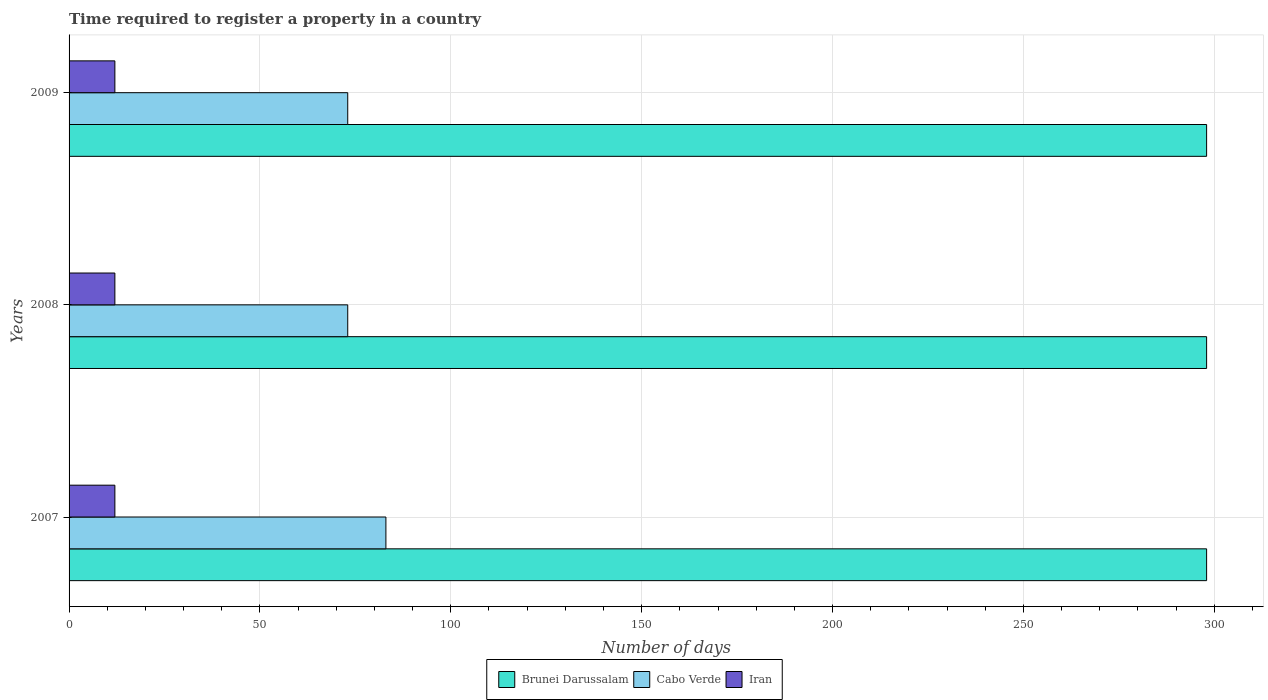Are the number of bars per tick equal to the number of legend labels?
Offer a very short reply. Yes. Are the number of bars on each tick of the Y-axis equal?
Keep it short and to the point. Yes. What is the label of the 1st group of bars from the top?
Your response must be concise. 2009. In how many cases, is the number of bars for a given year not equal to the number of legend labels?
Offer a very short reply. 0. What is the number of days required to register a property in Brunei Darussalam in 2008?
Your answer should be very brief. 298. Across all years, what is the maximum number of days required to register a property in Iran?
Provide a succinct answer. 12. In which year was the number of days required to register a property in Brunei Darussalam maximum?
Your answer should be very brief. 2007. In which year was the number of days required to register a property in Cabo Verde minimum?
Offer a very short reply. 2008. What is the total number of days required to register a property in Iran in the graph?
Give a very brief answer. 36. What is the difference between the number of days required to register a property in Brunei Darussalam in 2007 and that in 2009?
Provide a short and direct response. 0. What is the difference between the number of days required to register a property in Brunei Darussalam in 2009 and the number of days required to register a property in Iran in 2008?
Provide a short and direct response. 286. What is the average number of days required to register a property in Brunei Darussalam per year?
Make the answer very short. 298. In the year 2008, what is the difference between the number of days required to register a property in Iran and number of days required to register a property in Cabo Verde?
Your answer should be compact. -61. What is the ratio of the number of days required to register a property in Iran in 2007 to that in 2009?
Your answer should be very brief. 1. Is the difference between the number of days required to register a property in Iran in 2007 and 2008 greater than the difference between the number of days required to register a property in Cabo Verde in 2007 and 2008?
Ensure brevity in your answer.  No. What is the difference between the highest and the lowest number of days required to register a property in Iran?
Offer a terse response. 0. In how many years, is the number of days required to register a property in Iran greater than the average number of days required to register a property in Iran taken over all years?
Your answer should be very brief. 0. What does the 1st bar from the top in 2008 represents?
Provide a succinct answer. Iran. What does the 3rd bar from the bottom in 2007 represents?
Your response must be concise. Iran. Is it the case that in every year, the sum of the number of days required to register a property in Cabo Verde and number of days required to register a property in Iran is greater than the number of days required to register a property in Brunei Darussalam?
Ensure brevity in your answer.  No. How many years are there in the graph?
Keep it short and to the point. 3. What is the difference between two consecutive major ticks on the X-axis?
Your answer should be compact. 50. Does the graph contain any zero values?
Your answer should be very brief. No. Where does the legend appear in the graph?
Provide a succinct answer. Bottom center. How many legend labels are there?
Your response must be concise. 3. How are the legend labels stacked?
Provide a succinct answer. Horizontal. What is the title of the graph?
Provide a succinct answer. Time required to register a property in a country. What is the label or title of the X-axis?
Offer a very short reply. Number of days. What is the label or title of the Y-axis?
Ensure brevity in your answer.  Years. What is the Number of days in Brunei Darussalam in 2007?
Give a very brief answer. 298. What is the Number of days in Iran in 2007?
Keep it short and to the point. 12. What is the Number of days of Brunei Darussalam in 2008?
Ensure brevity in your answer.  298. What is the Number of days in Cabo Verde in 2008?
Offer a very short reply. 73. What is the Number of days in Iran in 2008?
Provide a short and direct response. 12. What is the Number of days of Brunei Darussalam in 2009?
Provide a succinct answer. 298. What is the Number of days in Cabo Verde in 2009?
Your response must be concise. 73. What is the Number of days of Iran in 2009?
Your answer should be compact. 12. Across all years, what is the maximum Number of days in Brunei Darussalam?
Provide a succinct answer. 298. Across all years, what is the maximum Number of days of Iran?
Ensure brevity in your answer.  12. Across all years, what is the minimum Number of days of Brunei Darussalam?
Give a very brief answer. 298. Across all years, what is the minimum Number of days of Cabo Verde?
Provide a succinct answer. 73. Across all years, what is the minimum Number of days in Iran?
Your answer should be very brief. 12. What is the total Number of days in Brunei Darussalam in the graph?
Offer a very short reply. 894. What is the total Number of days of Cabo Verde in the graph?
Make the answer very short. 229. What is the difference between the Number of days of Brunei Darussalam in 2007 and that in 2008?
Ensure brevity in your answer.  0. What is the difference between the Number of days of Iran in 2007 and that in 2008?
Make the answer very short. 0. What is the difference between the Number of days in Cabo Verde in 2007 and that in 2009?
Offer a very short reply. 10. What is the difference between the Number of days of Iran in 2007 and that in 2009?
Provide a succinct answer. 0. What is the difference between the Number of days in Brunei Darussalam in 2008 and that in 2009?
Keep it short and to the point. 0. What is the difference between the Number of days of Brunei Darussalam in 2007 and the Number of days of Cabo Verde in 2008?
Make the answer very short. 225. What is the difference between the Number of days in Brunei Darussalam in 2007 and the Number of days in Iran in 2008?
Keep it short and to the point. 286. What is the difference between the Number of days in Cabo Verde in 2007 and the Number of days in Iran in 2008?
Offer a very short reply. 71. What is the difference between the Number of days in Brunei Darussalam in 2007 and the Number of days in Cabo Verde in 2009?
Provide a short and direct response. 225. What is the difference between the Number of days of Brunei Darussalam in 2007 and the Number of days of Iran in 2009?
Offer a very short reply. 286. What is the difference between the Number of days in Brunei Darussalam in 2008 and the Number of days in Cabo Verde in 2009?
Your response must be concise. 225. What is the difference between the Number of days in Brunei Darussalam in 2008 and the Number of days in Iran in 2009?
Offer a very short reply. 286. What is the average Number of days in Brunei Darussalam per year?
Provide a succinct answer. 298. What is the average Number of days in Cabo Verde per year?
Your response must be concise. 76.33. What is the average Number of days in Iran per year?
Your answer should be very brief. 12. In the year 2007, what is the difference between the Number of days of Brunei Darussalam and Number of days of Cabo Verde?
Keep it short and to the point. 215. In the year 2007, what is the difference between the Number of days in Brunei Darussalam and Number of days in Iran?
Offer a terse response. 286. In the year 2008, what is the difference between the Number of days of Brunei Darussalam and Number of days of Cabo Verde?
Keep it short and to the point. 225. In the year 2008, what is the difference between the Number of days in Brunei Darussalam and Number of days in Iran?
Give a very brief answer. 286. In the year 2009, what is the difference between the Number of days of Brunei Darussalam and Number of days of Cabo Verde?
Provide a short and direct response. 225. In the year 2009, what is the difference between the Number of days of Brunei Darussalam and Number of days of Iran?
Provide a succinct answer. 286. What is the ratio of the Number of days of Cabo Verde in 2007 to that in 2008?
Your response must be concise. 1.14. What is the ratio of the Number of days of Brunei Darussalam in 2007 to that in 2009?
Give a very brief answer. 1. What is the ratio of the Number of days of Cabo Verde in 2007 to that in 2009?
Make the answer very short. 1.14. What is the ratio of the Number of days of Iran in 2007 to that in 2009?
Keep it short and to the point. 1. What is the difference between the highest and the second highest Number of days in Brunei Darussalam?
Your answer should be very brief. 0. What is the difference between the highest and the second highest Number of days in Iran?
Give a very brief answer. 0. What is the difference between the highest and the lowest Number of days of Brunei Darussalam?
Give a very brief answer. 0. 